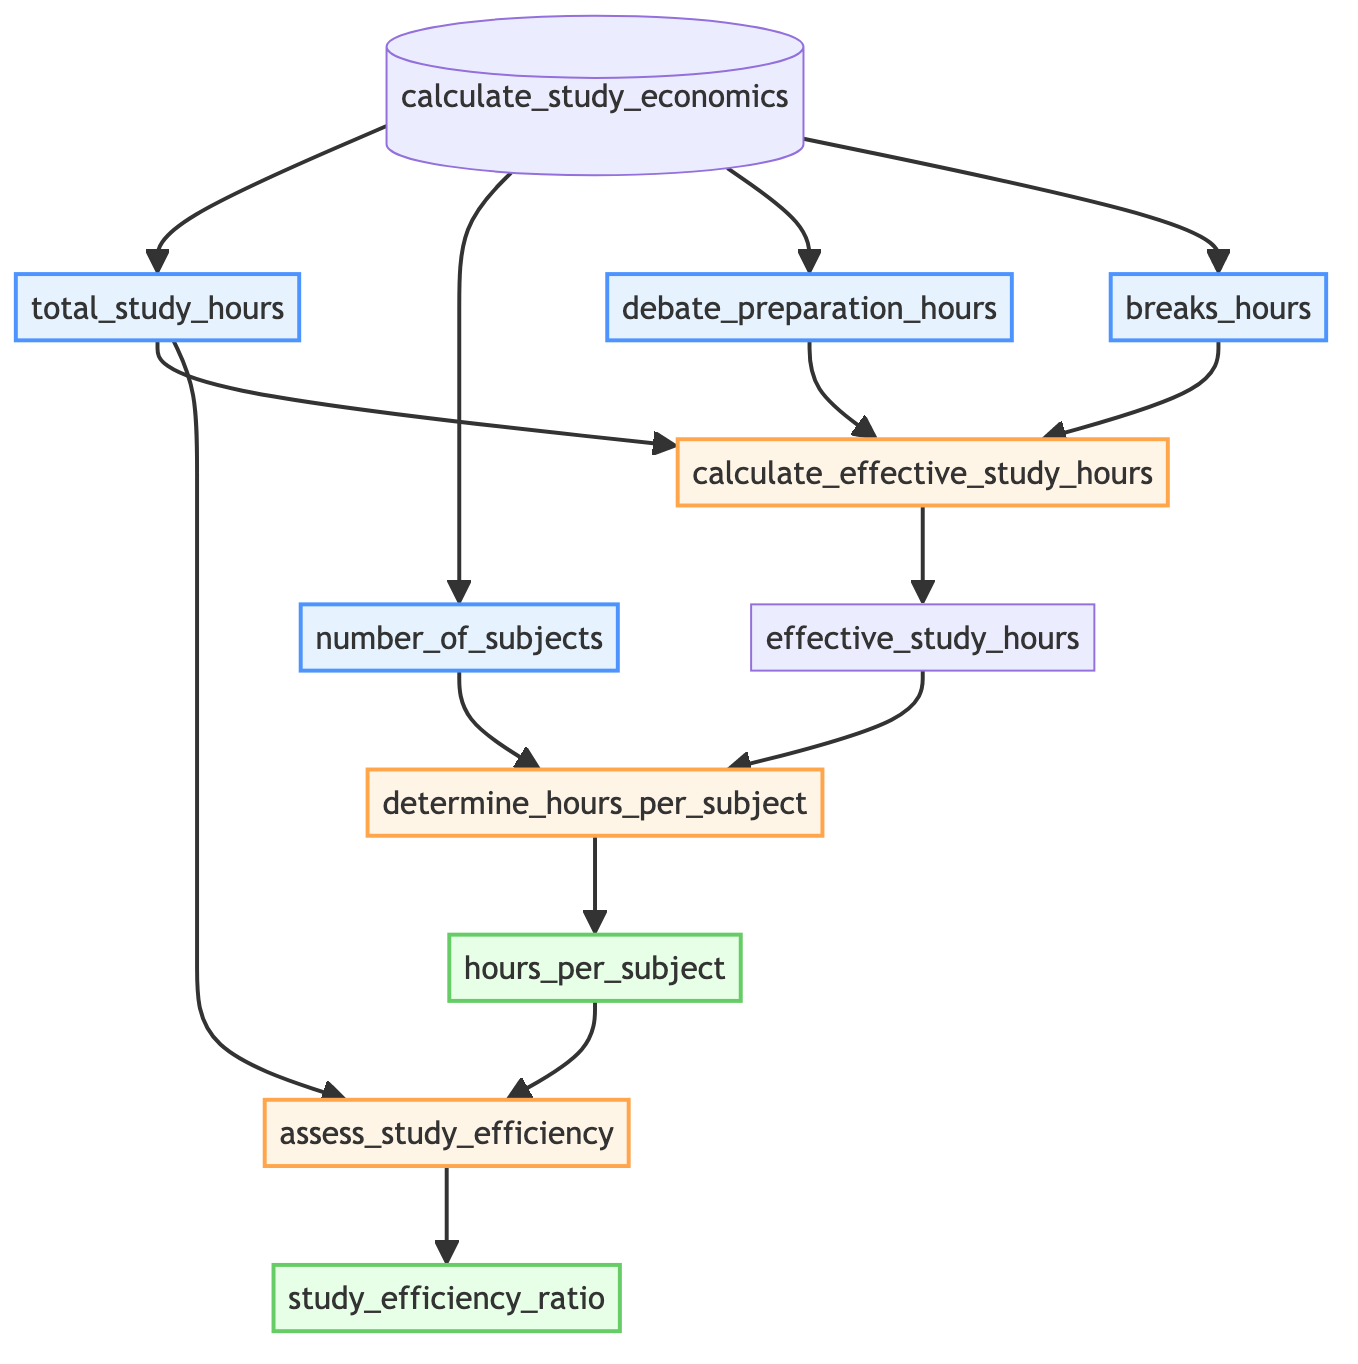What's the name of the function in this diagram? The name of the function is displayed prominently at the starting point of the diagram as "calculate_study_economics".
Answer: calculate_study_economics How many inputs does the function take? The diagram shows four inputs connected to the function node, which are total_study_hours, number_of_subjects, debate_preparation_hours, and breaks_hours.
Answer: 4 What is the output from the processing step "determine_hours_per_subject"? The output from the processing step "determine_hours_per_subject" is shown as hours_per_subject, indicating the hours allocated per subject based on the effective study hours.
Answer: hours_per_subject Which processing step follows the calculation of effective_study_hours? The processing step that follows "calculate_effective_study_hours" is "determine_hours_per_subject", showing the flow from calculating the effective hours to determining hours per subject.
Answer: determine_hours_per_subject What operation is performed to calculate effective_study_hours? The operation performed to calculate effective_study_hours is subtraction, which combines total_study_hours, debate_preparation_hours, and breaks_hours.
Answer: subtraction What is the relationship between hours_per_subject and study_efficiency_ratio? The relationship is that hours_per_subject is used as an input in the step "assess_study_efficiency" to compute the study_efficiency_ratio, indicating a flow from one to another.
Answer: input How is study_efficiency_ratio calculated? The study_efficiency_ratio is calculated by dividing hours_per_subject by total_study_hours, reflecting the efficiency of study time relative to the total available hours.
Answer: division Identify three data types of inputs in the diagram. The diagram features one float input named total_study_hours, one integer input named number_of_subjects, and two float inputs named debate_preparation_hours and breaks_hours.
Answer: float, int, float What is the last output calculated in the flowchart? The last output calculated in the flowchart is the study_efficiency_ratio, which is derived from operations performed on the preceding outputs and inputs.
Answer: study_efficiency_ratio 